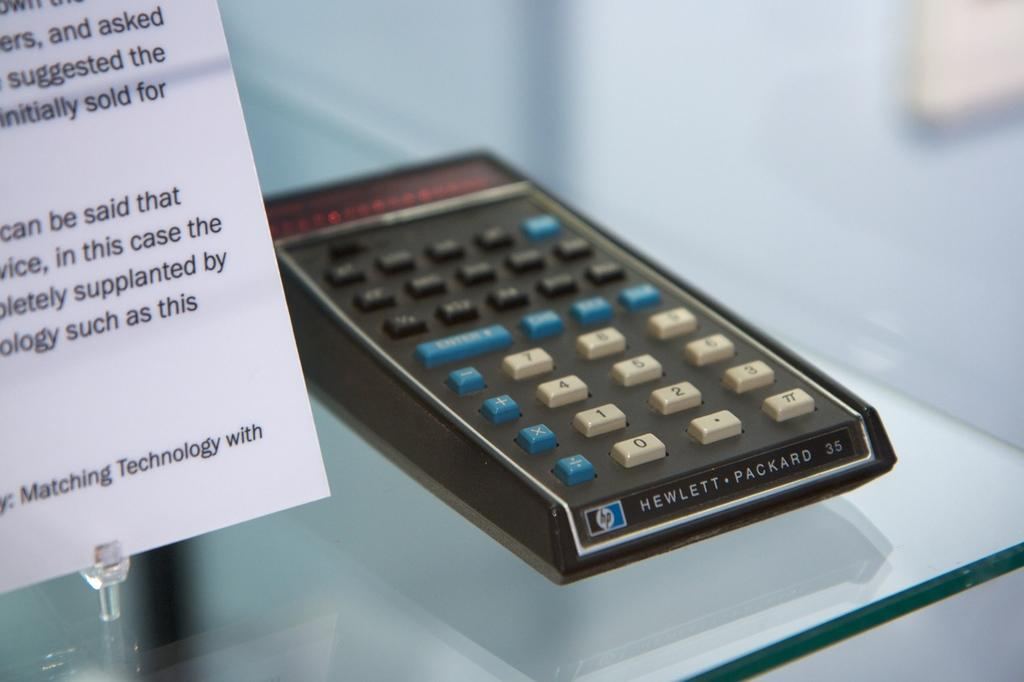<image>
Relay a brief, clear account of the picture shown. A Hewlett-Packard calculator from many, many years back is displayed on a glass shelf. 